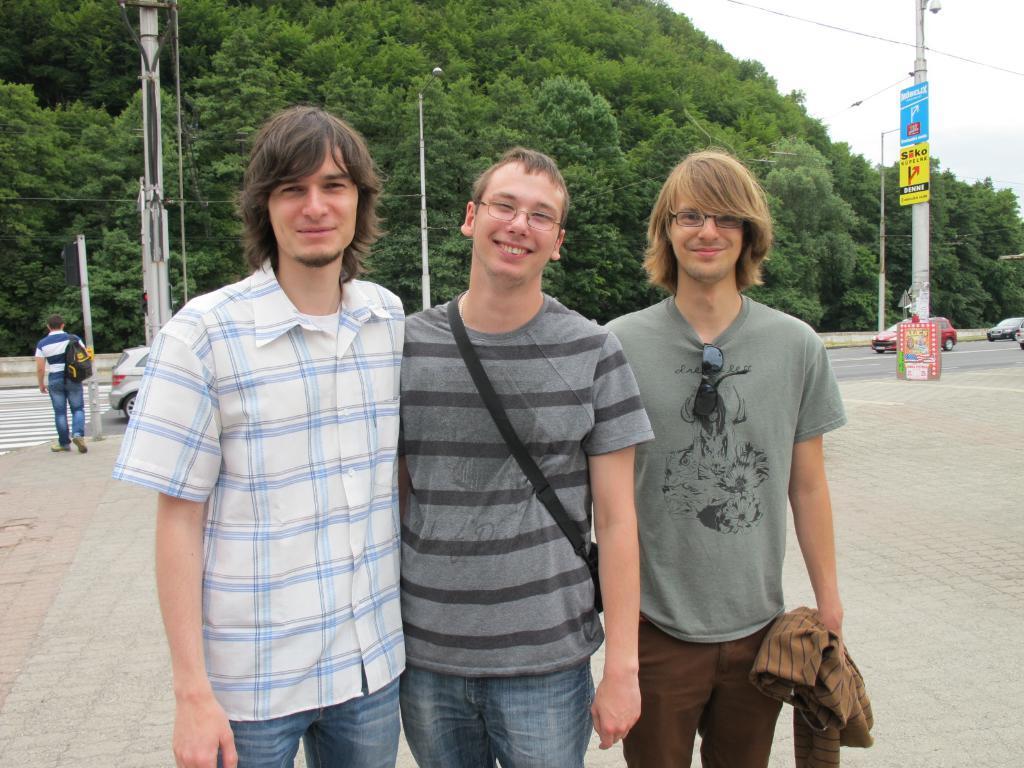Please provide a concise description of this image. There are three persons standing and there are few vehicles,trees and two poles in the background. 